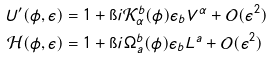<formula> <loc_0><loc_0><loc_500><loc_500>U ^ { \prime } ( \phi , \epsilon ) & = 1 + \i i \mathcal { K } _ { \alpha } ^ { b } ( \phi ) \epsilon _ { b } V ^ { \alpha } + \mathcal { O } ( \epsilon ^ { 2 } ) \\ \mathcal { H } ( \phi , \epsilon ) & = 1 + \i i \Omega _ { a } ^ { b } ( \phi ) \epsilon _ { b } L ^ { a } + \mathcal { O } ( \epsilon ^ { 2 } )</formula> 